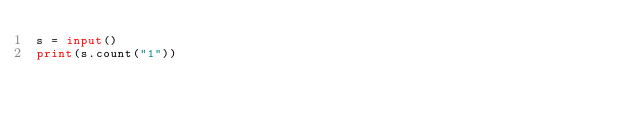Convert code to text. <code><loc_0><loc_0><loc_500><loc_500><_Python_>s = input()
print(s.count("1"))</code> 